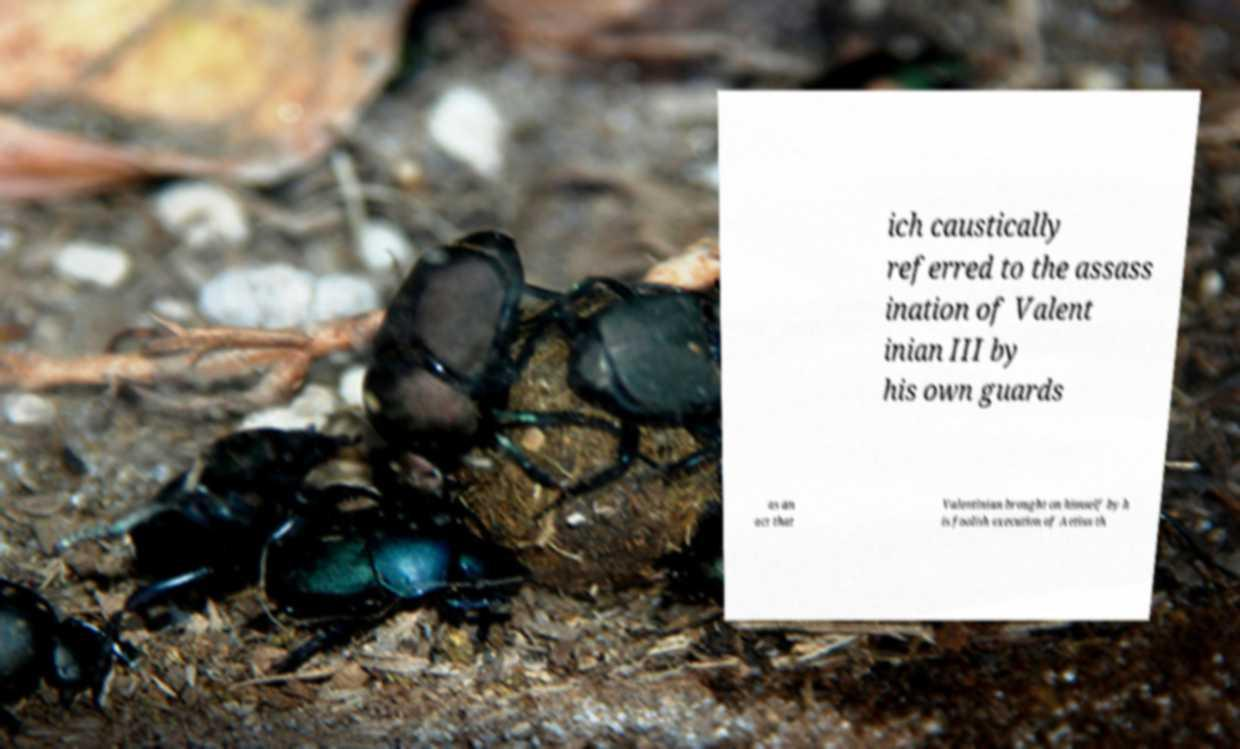There's text embedded in this image that I need extracted. Can you transcribe it verbatim? ich caustically referred to the assass ination of Valent inian III by his own guards as an act that Valentinian brought on himself by h is foolish execution of Aetius th 